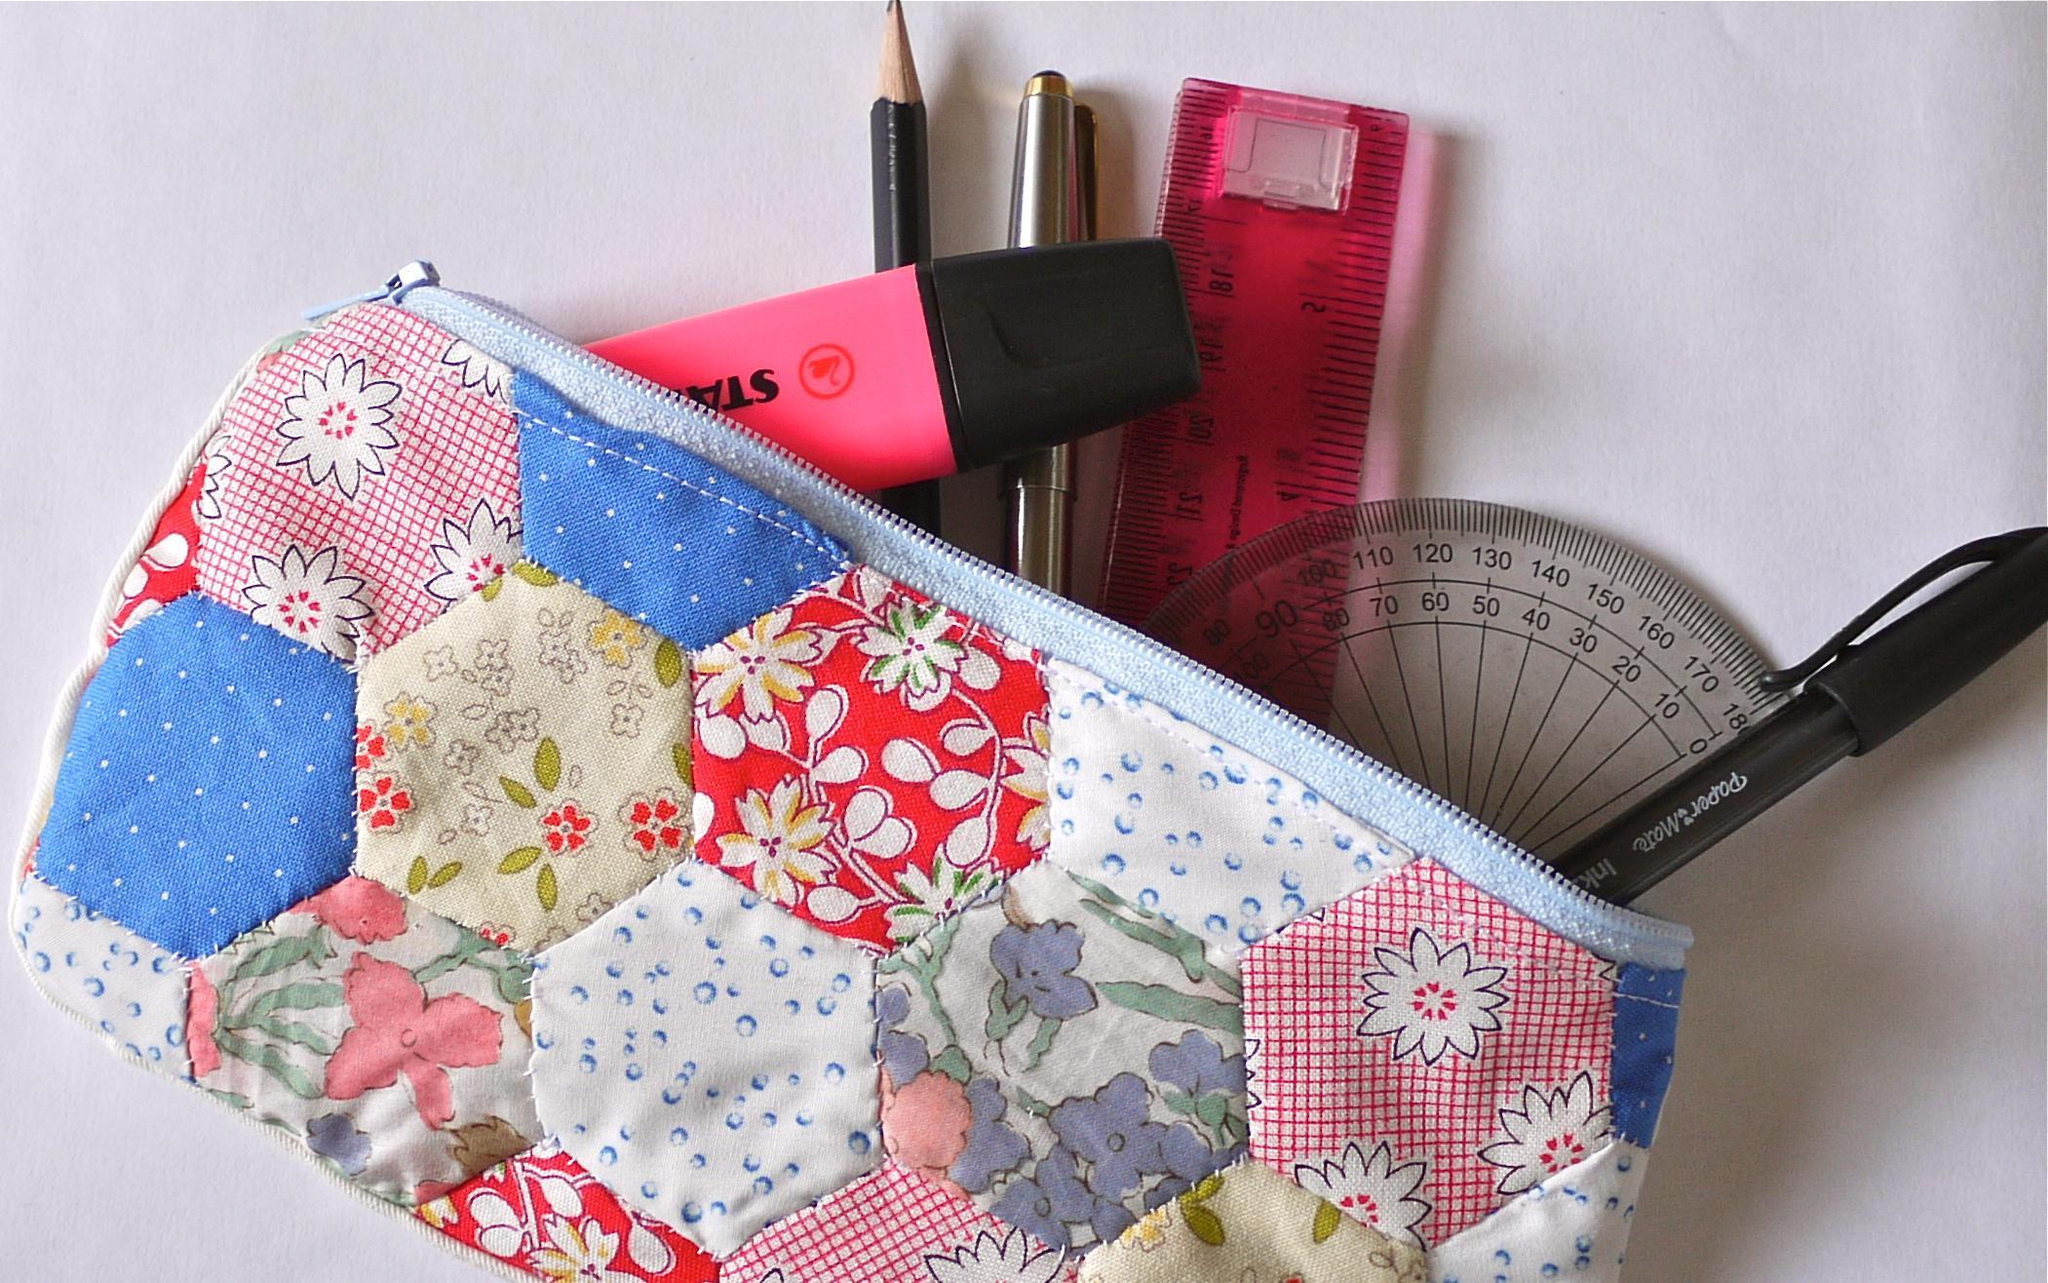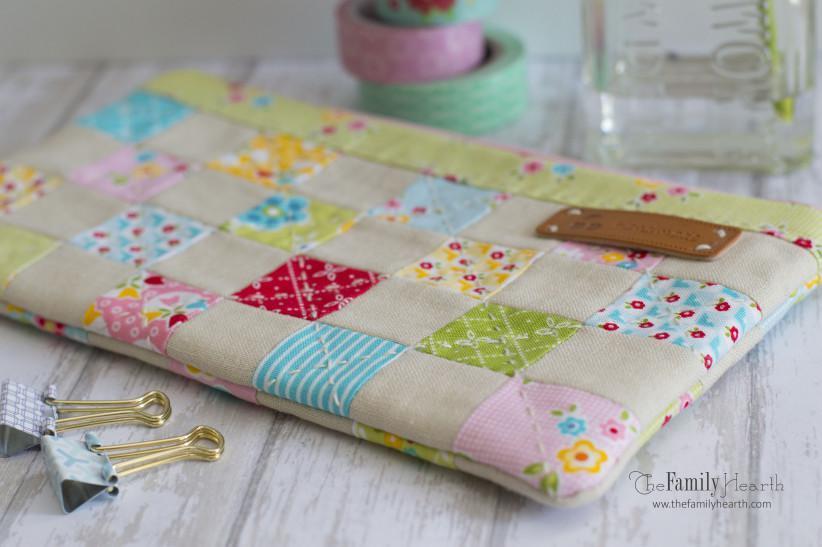The first image is the image on the left, the second image is the image on the right. Evaluate the accuracy of this statement regarding the images: "Exactly one pouch is open with office supplies sticking out.". Is it true? Answer yes or no. Yes. The first image is the image on the left, the second image is the image on the right. For the images shown, is this caption "One image shows two tube-shaped zipper cases with patchwork patterns displayed end-first, and the other image shows one flat zipper case with a patterned exterior." true? Answer yes or no. No. 